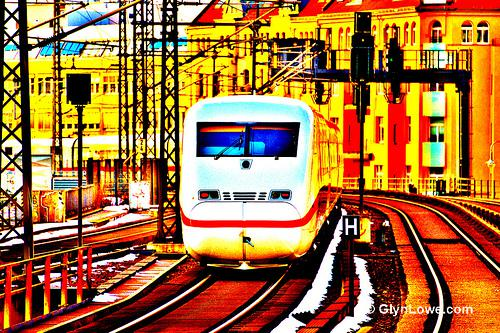Question: when was the picture taken?
Choices:
A. Daytime.
B. At dawn.
C. At dusk.
D. In the morning.
Answer with the letter. Answer: A Question: where is a train?
Choices:
A. In a museum.
B. On train tracks.
C. At the depot.
D. In the shed.
Answer with the letter. Answer: B Question: what is white?
Choices:
A. The car.
B. Train.
C. The truck.
D. The van.
Answer with the letter. Answer: B 